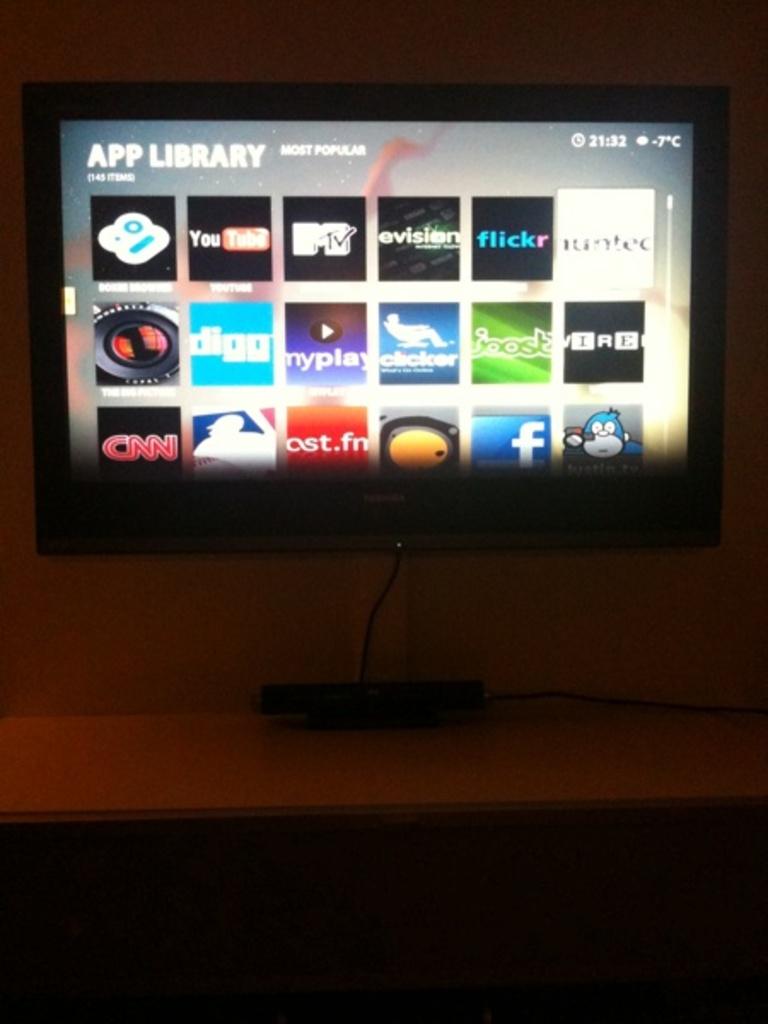What sort of library is this?
Offer a very short reply. App. Is this a smart tv?
Provide a succinct answer. Yes. 